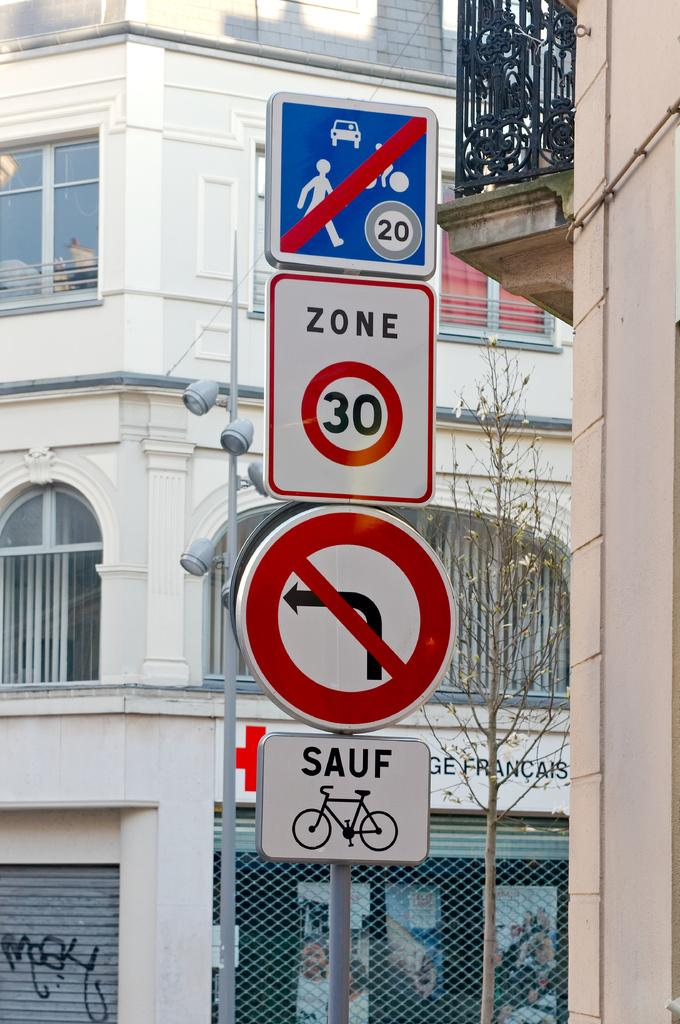<image>
Provide a brief description of the given image. some street signs that include ZONE 30, Sauf bikes and no left turn. 